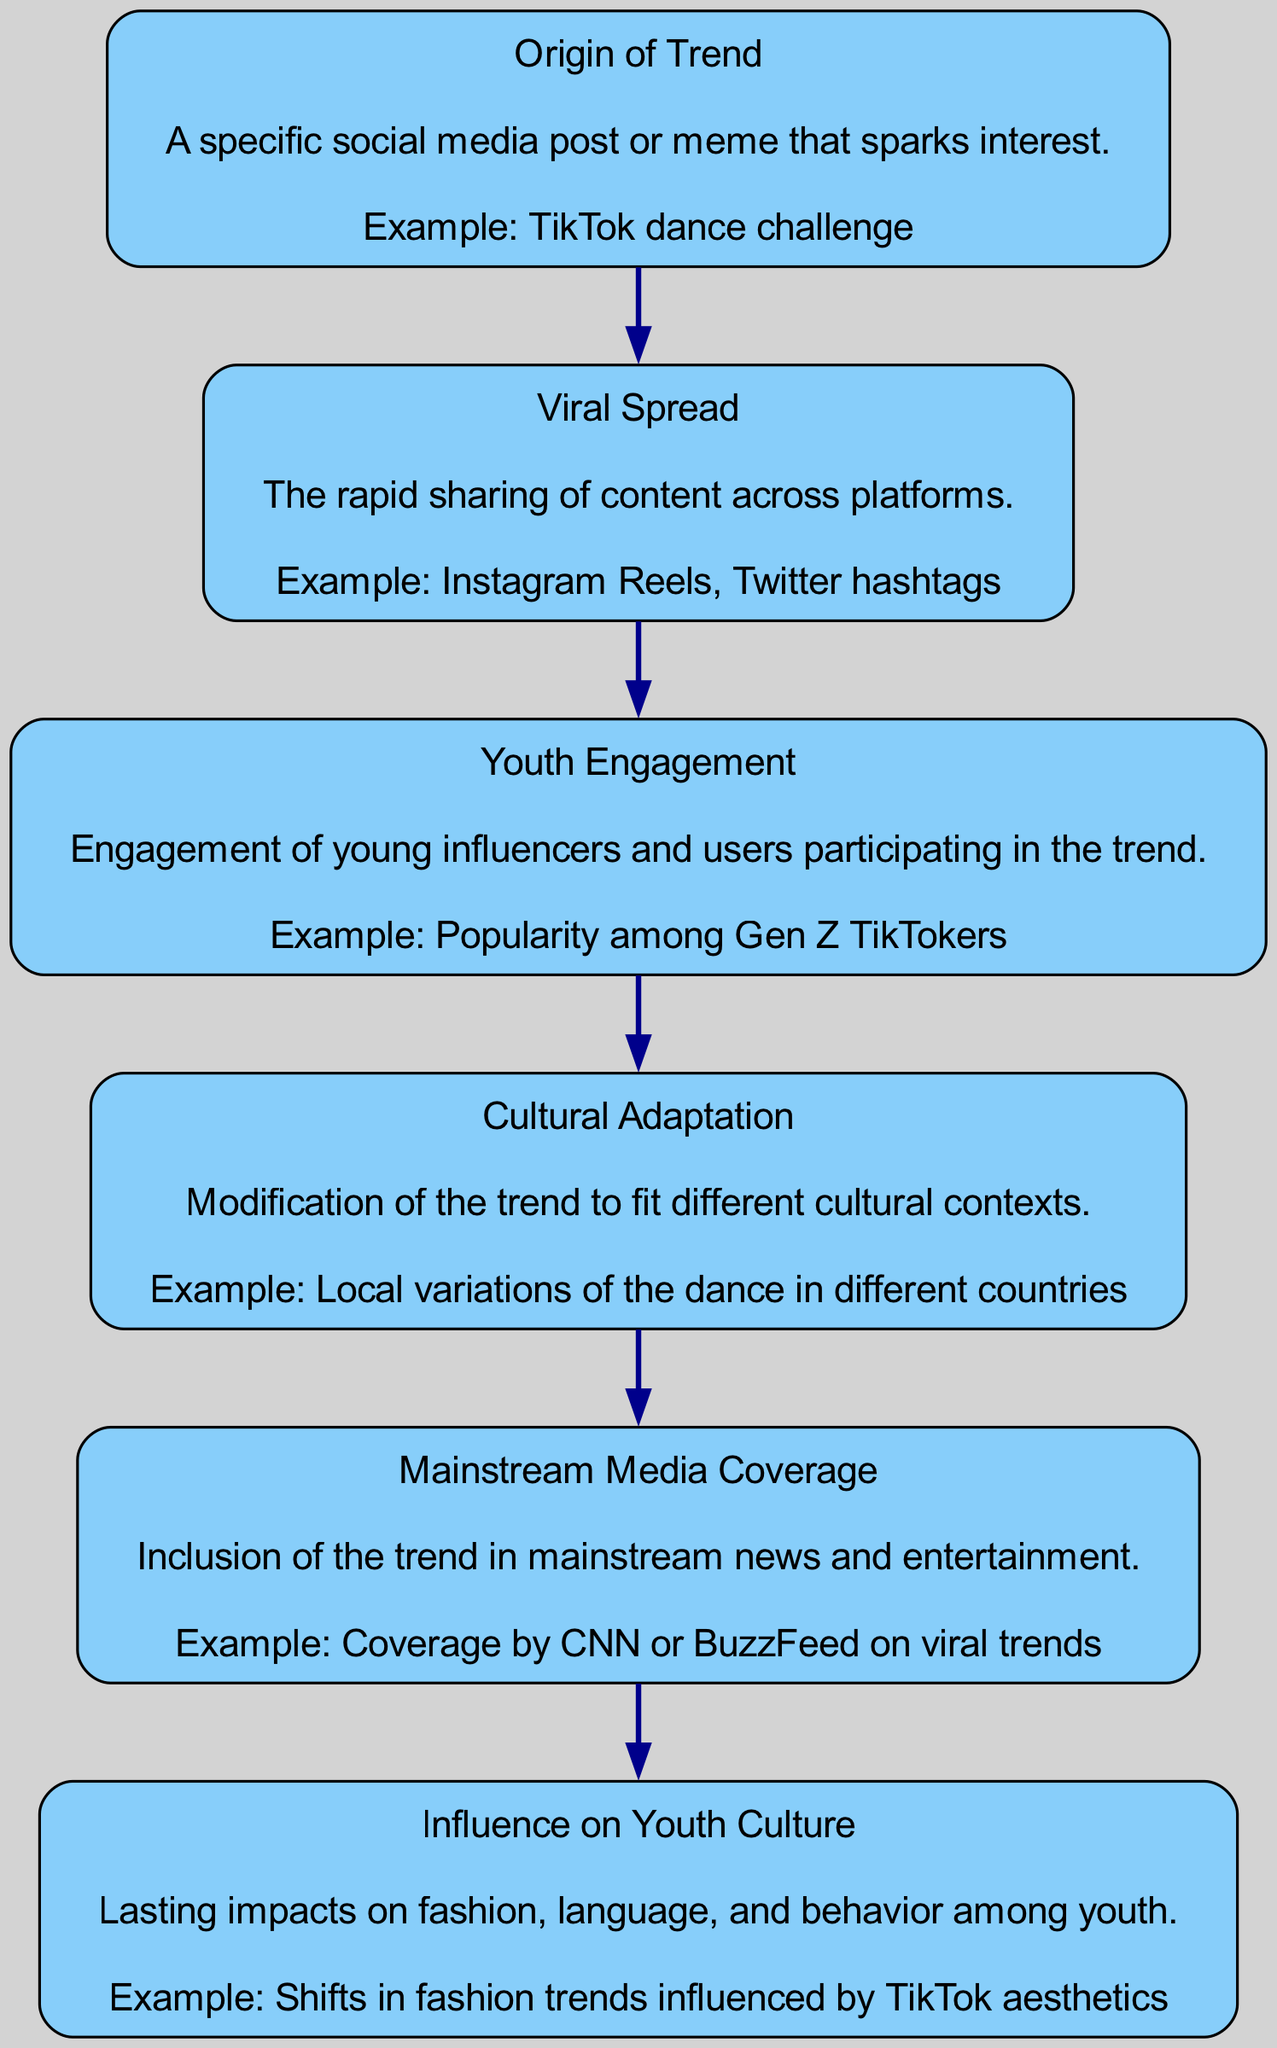What is the first node in the diagram? The first node in the diagram is labeled "Origin of Trend," indicating the starting point of the viral trend journey.
Answer: Origin of Trend How many elements are there in total in the flow chart? There are six elements in total as represented by each node in the flow chart: Origin of Trend, Viral Spread, Youth Engagement, Cultural Adaptation, Mainstream Media Coverage, and Influence on Youth Culture.
Answer: 6 What is the last step that follows Youth Engagement? The node that follows Youth Engagement is Cultural Adaptation, indicating the progression from youth participation to the adaptation of the trend.
Answer: Cultural Adaptation Which element describes how trends are modified in different cultural contexts? The element that describes the modification of trends in different cultural contexts is Cultural Adaptation.
Answer: Cultural Adaptation What is the relationship between Viral Spread and Mainstream Media Coverage? Viral Spread leads to Mainstream Media Coverage, indicating that as a trend spreads rapidly, it eventually garners coverage from mainstream media outlets.
Answer: Viral Spread leads to Mainstream Media Coverage What is the example provided for the Influence on Youth Culture? The example provided for Influence on Youth Culture is a shift in fashion trends influenced by TikTok aesthetics, representing how viral trends impact youth culture directly.
Answer: Shifts in fashion trends influenced by TikTok aesthetics What type of engagement is highlighted in the Youth Engagement node? The Youth Engagement node highlights the engagement of young influencers and users as they participate in the viral trend.
Answer: Young influencers and users What comes after Mainstream Media Coverage in the flow? The element that comes after Mainstream Media Coverage is Influence on Youth Culture, indicating the direct effects of media coverage on youth culture.
Answer: Influence on Youth Culture What is the example given for the Origins of Trend? The example given for the Origins of Trend is a TikTok dance challenge, which serves as a specific instance that can ignite a social media trend.
Answer: TikTok dance challenge 